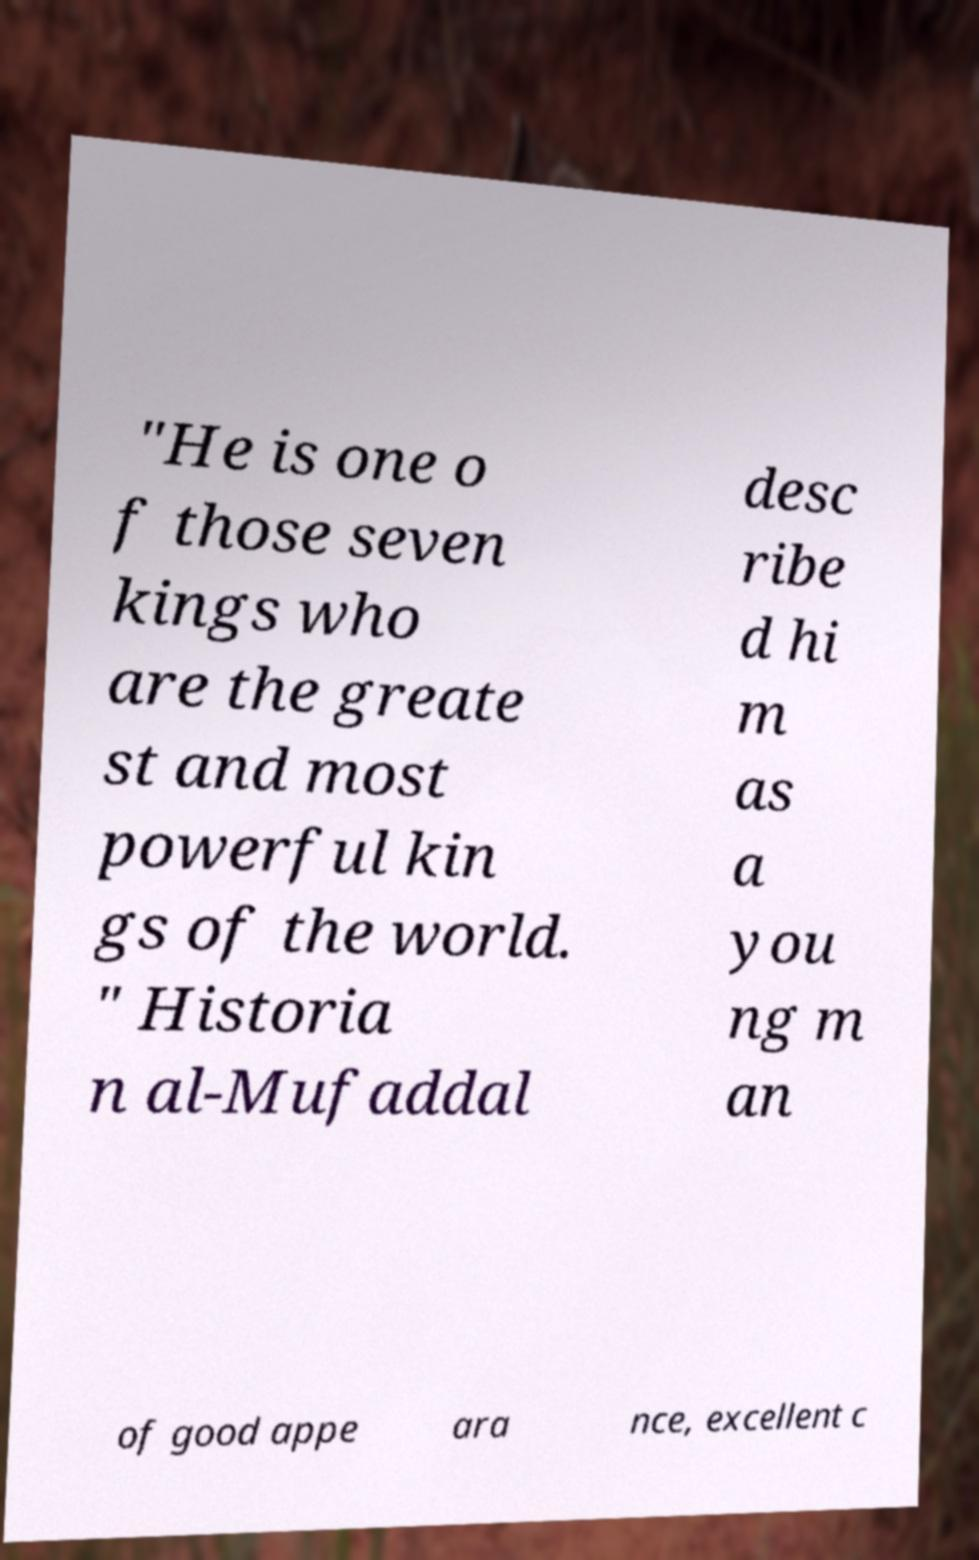I need the written content from this picture converted into text. Can you do that? "He is one o f those seven kings who are the greate st and most powerful kin gs of the world. " Historia n al-Mufaddal desc ribe d hi m as a you ng m an of good appe ara nce, excellent c 